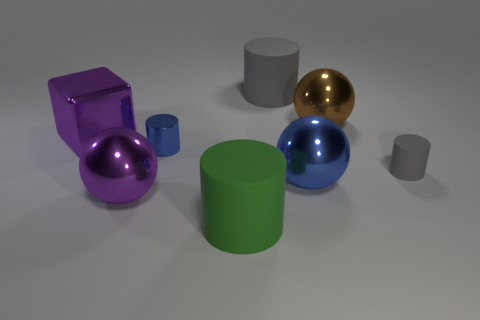There is a big cylinder that is the same color as the tiny rubber object; what is its material?
Your answer should be very brief. Rubber. How many metal things have the same color as the big cube?
Offer a terse response. 1. Is the material of the green object the same as the tiny cylinder that is right of the big gray cylinder?
Give a very brief answer. Yes. Are there more small blue cylinders that are in front of the green matte cylinder than brown balls?
Your answer should be very brief. No. There is a big cube; is it the same color as the large metallic ball to the left of the big green cylinder?
Your answer should be compact. Yes. Is the number of large things on the left side of the metal cube the same as the number of small gray objects in front of the large purple metallic sphere?
Offer a very short reply. Yes. There is a blue object left of the big gray matte cylinder; what material is it?
Make the answer very short. Metal. What number of objects are things that are in front of the purple ball or green things?
Provide a short and direct response. 1. How many other things are the same shape as the large green object?
Keep it short and to the point. 3. There is a gray matte thing behind the large shiny block; is its shape the same as the tiny blue shiny thing?
Ensure brevity in your answer.  Yes. 